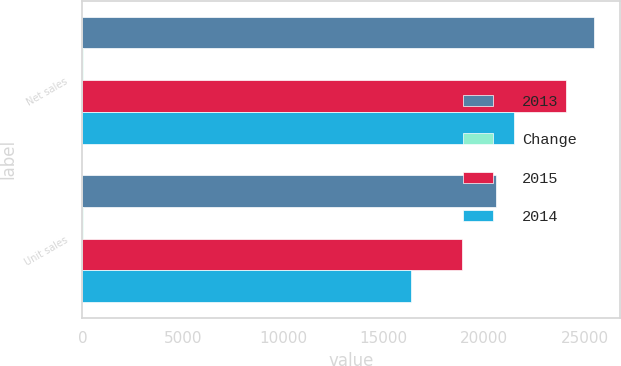<chart> <loc_0><loc_0><loc_500><loc_500><stacked_bar_chart><ecel><fcel>Net sales<fcel>Unit sales<nl><fcel>2013<fcel>25471<fcel>20587<nl><fcel>Change<fcel>6<fcel>9<nl><fcel>2015<fcel>24079<fcel>18906<nl><fcel>2014<fcel>21483<fcel>16341<nl></chart> 